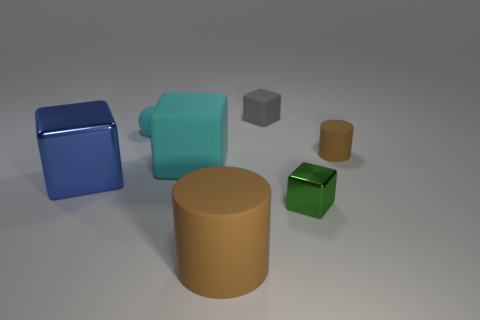What is the object that is both in front of the tiny cyan object and on the left side of the large cyan object made of?
Give a very brief answer. Metal. Are there any cyan things?
Provide a succinct answer. Yes. There is a small object that is made of the same material as the big blue cube; what is its shape?
Your answer should be very brief. Cube. Do the blue thing and the rubber object behind the cyan matte sphere have the same shape?
Offer a terse response. Yes. What material is the blue cube behind the cube that is in front of the blue object?
Offer a terse response. Metal. What number of other things are there of the same shape as the tiny green metallic thing?
Keep it short and to the point. 3. Is the shape of the large rubber object in front of the big cyan object the same as the metal thing that is on the left side of the big rubber cylinder?
Provide a succinct answer. No. What is the tiny green object made of?
Your answer should be very brief. Metal. What material is the tiny cube to the right of the gray object?
Your answer should be very brief. Metal. Is there any other thing that is the same color as the large metal block?
Make the answer very short. No. 